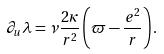Convert formula to latex. <formula><loc_0><loc_0><loc_500><loc_500>\partial _ { u } \lambda = \nu \frac { 2 \kappa } { r ^ { 2 } } \left ( \varpi - \frac { e ^ { 2 } } { r } \right ) .</formula> 